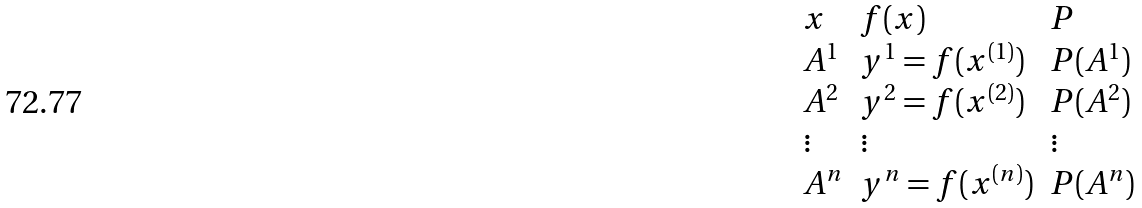Convert formula to latex. <formula><loc_0><loc_0><loc_500><loc_500>\begin{array} { l l l } x & f ( x ) & P \\ A ^ { 1 } & y ^ { 1 } = f ( x ^ { ( 1 ) } ) & P ( A ^ { 1 } ) \\ A ^ { 2 } & y ^ { 2 } = f ( x ^ { ( 2 ) } ) & P ( A ^ { 2 } ) \\ \vdots & \vdots & \vdots \\ A ^ { n } & y ^ { n } = f ( x ^ { ( n ) } ) & P ( A ^ { n } ) \end{array}</formula> 